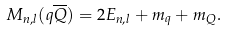<formula> <loc_0><loc_0><loc_500><loc_500>M _ { n , l } ( q \overline { Q } ) = 2 E _ { n , l } + m _ { q } + m _ { Q } .</formula> 